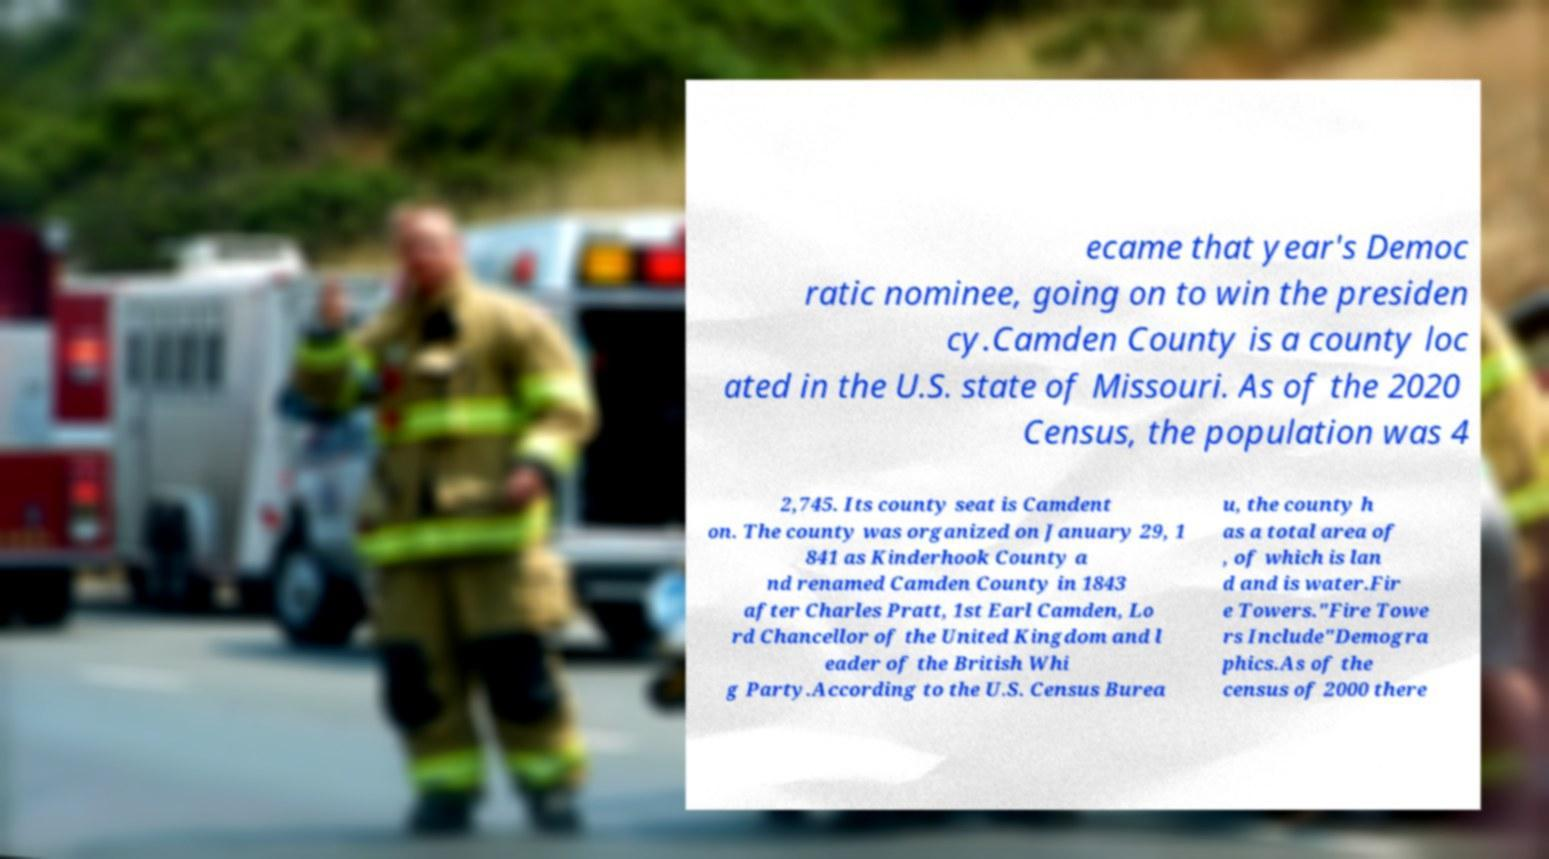Could you extract and type out the text from this image? ecame that year's Democ ratic nominee, going on to win the presiden cy.Camden County is a county loc ated in the U.S. state of Missouri. As of the 2020 Census, the population was 4 2,745. Its county seat is Camdent on. The county was organized on January 29, 1 841 as Kinderhook County a nd renamed Camden County in 1843 after Charles Pratt, 1st Earl Camden, Lo rd Chancellor of the United Kingdom and l eader of the British Whi g Party.According to the U.S. Census Burea u, the county h as a total area of , of which is lan d and is water.Fir e Towers."Fire Towe rs Include"Demogra phics.As of the census of 2000 there 